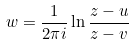<formula> <loc_0><loc_0><loc_500><loc_500>w = \frac { 1 } { 2 \pi i } \ln { \frac { z - u } { z - v } }</formula> 